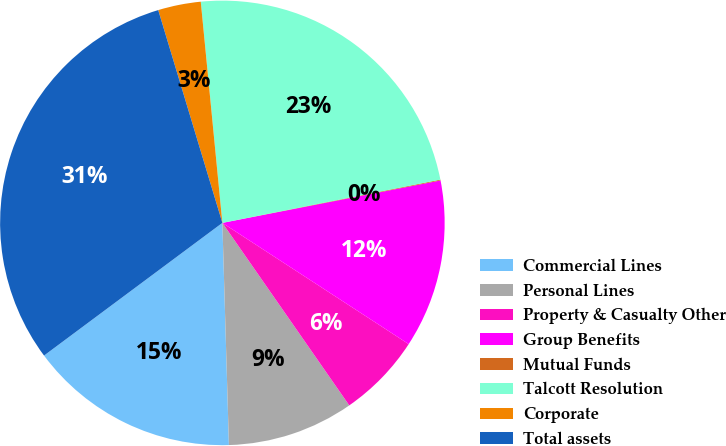Convert chart to OTSL. <chart><loc_0><loc_0><loc_500><loc_500><pie_chart><fcel>Commercial Lines<fcel>Personal Lines<fcel>Property & Casualty Other<fcel>Group Benefits<fcel>Mutual Funds<fcel>Talcott Resolution<fcel>Corporate<fcel>Total assets<nl><fcel>15.29%<fcel>9.2%<fcel>6.15%<fcel>12.24%<fcel>0.06%<fcel>23.43%<fcel>3.11%<fcel>30.52%<nl></chart> 